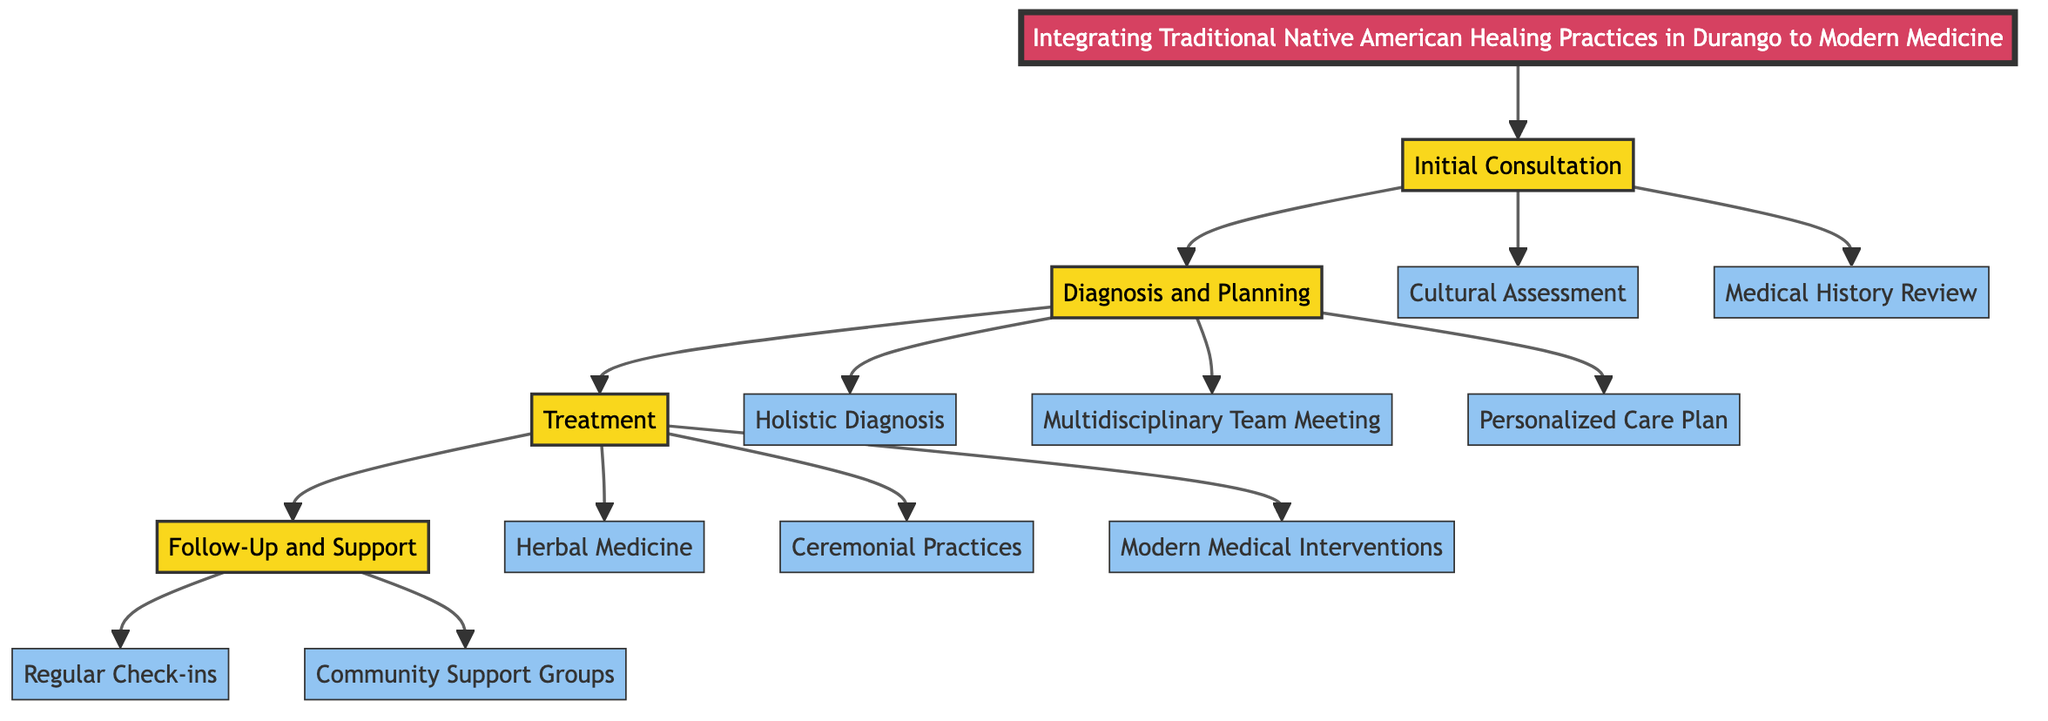What is the title of the pathway? The title of the pathway is displayed at the top of the diagram, stating "Integrating Traditional Native American Healing Practices in Durango to Modern Medicine".
Answer: Integrating Traditional Native American Healing Practices in Durango to Modern Medicine How many stages are in the clinical pathway? The diagram outlines four distinct stages: Initial Consultation, Diagnosis and Planning, Treatment, and Follow-Up and Support.
Answer: Four What step follows the "Cultural Assessment"? The flow from the Initial Consultation indicates that after Cultural Assessment, the next step is Medical History Review.
Answer: Medical History Review What is included in the "Treatment" stage? The Treatment stage encompasses three steps: Herbal Medicine, Ceremonial Practices, and Modern Medical Interventions.
Answer: Herbal Medicine, Ceremonial Practices, Modern Medical Interventions Which team is involved in the "Diagnosis and Planning" stage? In the Diagnosis and Planning stage, the diagram shows that a Multidisciplinary Team Meeting involves both modern medical practitioners and Native healers.
Answer: Multidisciplinary Team Meeting What kind of support is encouraged in the Follow-Up stage? The Follow-Up and Support stage encourages participation in Community Support Groups that honor traditional practices.
Answer: Community Support Groups What is the final step in the clinical pathway? The flowchart indicates that the final step in the Follow-Up and Support stage is Regular Check-ins.
Answer: Regular Check-ins Which practices are integrated into the Personalized Care Plan? The Personalized Care Plan integrates traditional and modern treatments aimed at comprehensive care, as indicated in the Diagnosis and Planning stage.
Answer: Traditional and modern treatments What is the purpose of the "Holistic Diagnosis"? The Holistic Diagnosis uses a combination of modern diagnostic tools and traditional methods, such as sweat lodges and talking circles, according to the diagram.
Answer: Combination of modern diagnostic tools and traditional methods 